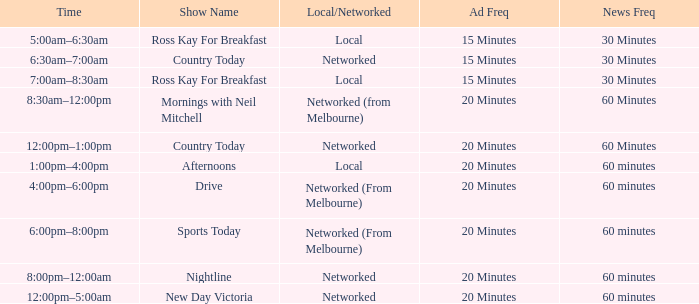What Time has Ad Freq of 15 minutes, and a Show Name of country today? 6:30am–7:00am. 